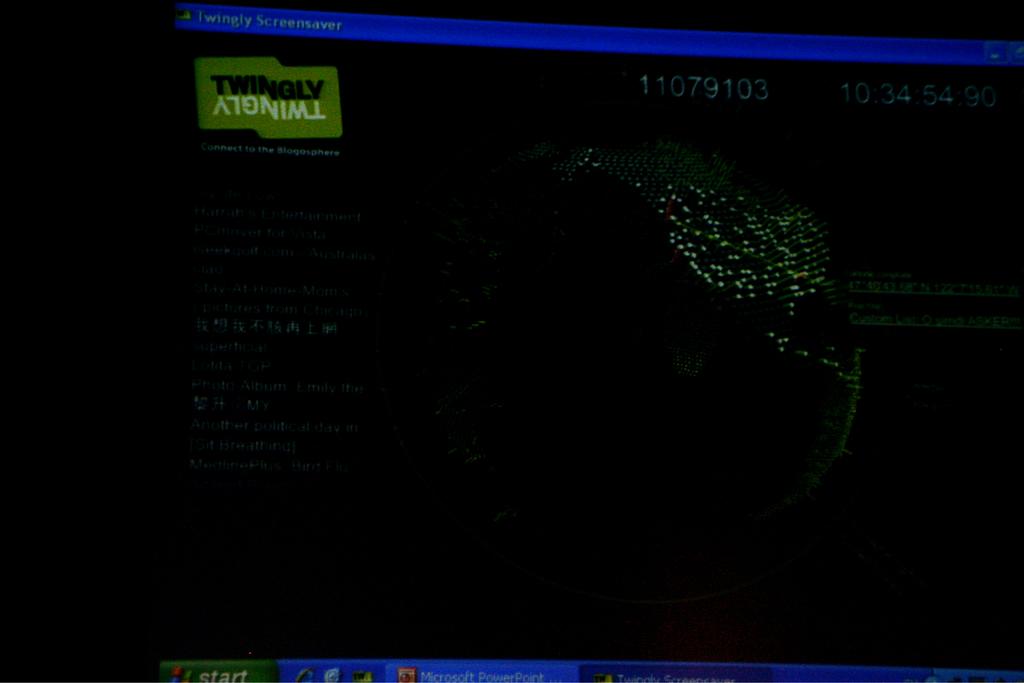What word is shown both right side up and upside down?
Offer a very short reply. Twingly. What does the green button say at the bottom?
Your answer should be compact. Start. 